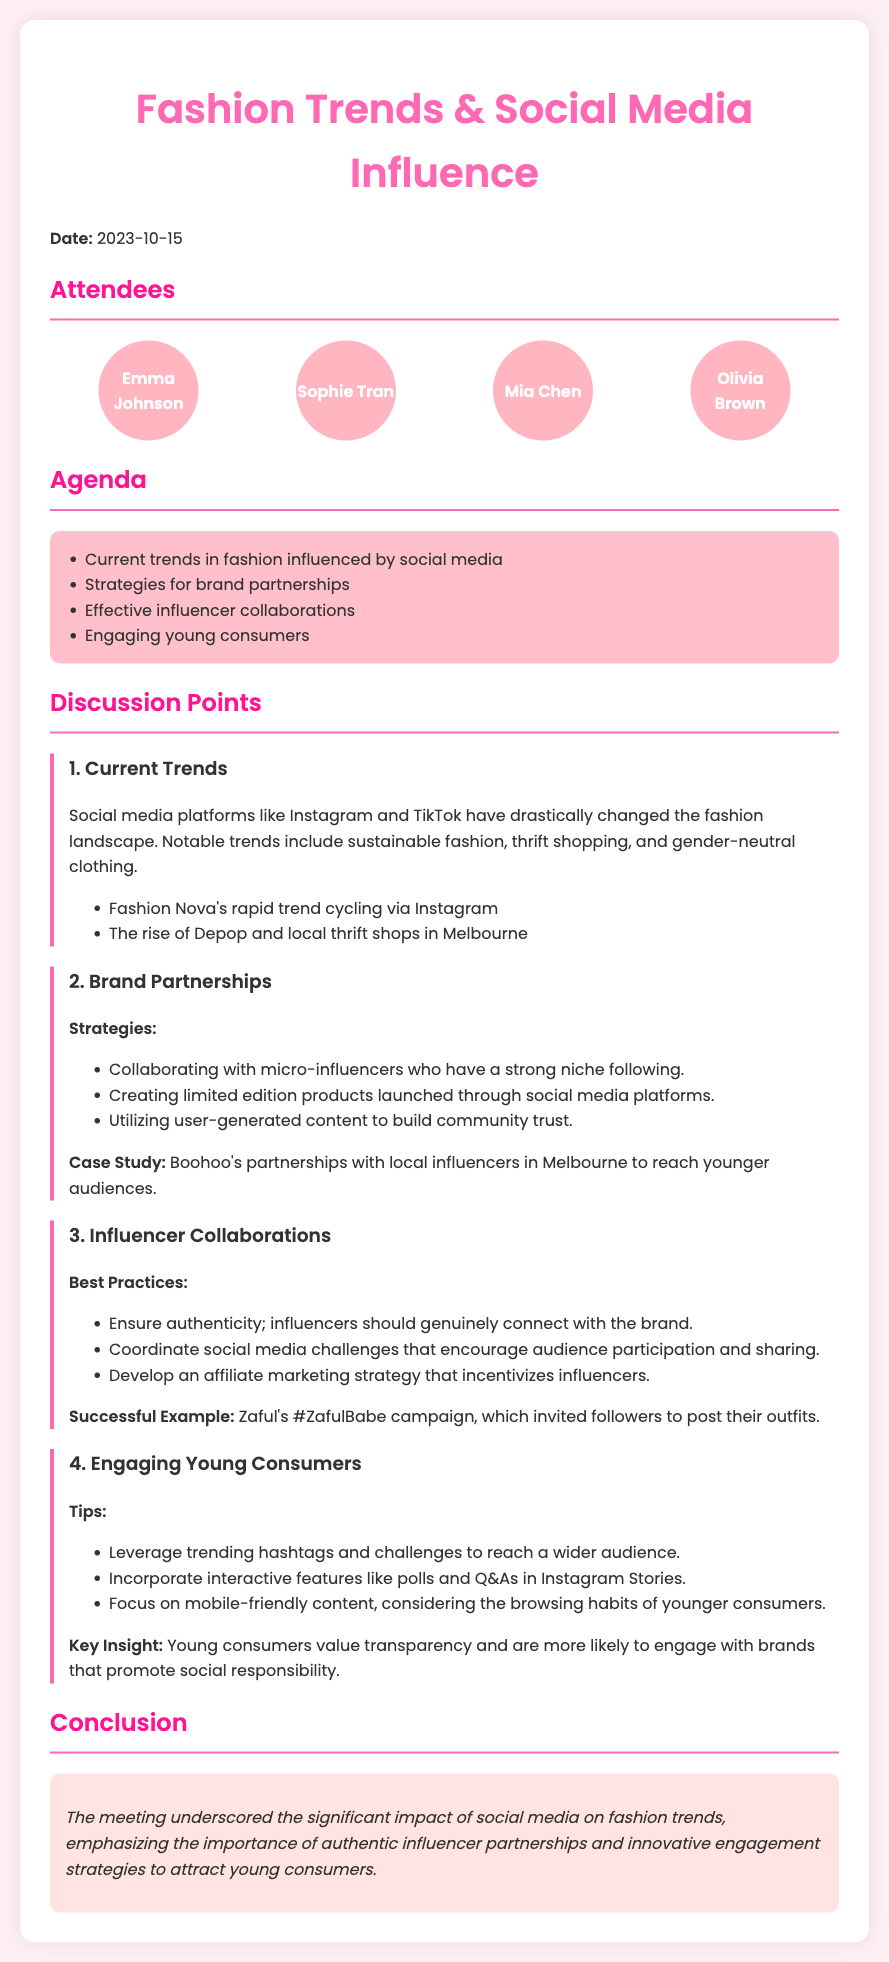What is the date of the meeting? The date of the meeting is provided in the header section of the document.
Answer: 2023-10-15 Who is an attendee of the meeting? The attendees are listed in a dedicated section of the document, highlighting individuals present.
Answer: Emma Johnson What is one current trend in fashion mentioned? The discussion points enumerate various trends influenced by social media in the fashion industry.
Answer: Sustainable fashion What is one strategy for brand partnerships? Strategies for brand partnerships are outlined in a specific discussion point regarding collaborations.
Answer: Collaborating with micro-influencers What is the title of the case study mentioned? The case study is highlighted in relation to brand partnerships and is specific to a brand's approach.
Answer: Boohoo's partnerships with local influencers in Melbourne What is a key insight regarding young consumers? Key insights are provided in the discussion about engaging young consumers, focusing on their values.
Answer: Transparency What campaign is mentioned as a successful example of influencer collaboration? The document mentions specific campaigns when discussing best practices for influencer collaborations.
Answer: #ZafulBabe What percentage of attendees are mentioned in the document? The number of attendees is enumerated in the attendees' section.
Answer: Four attendees 